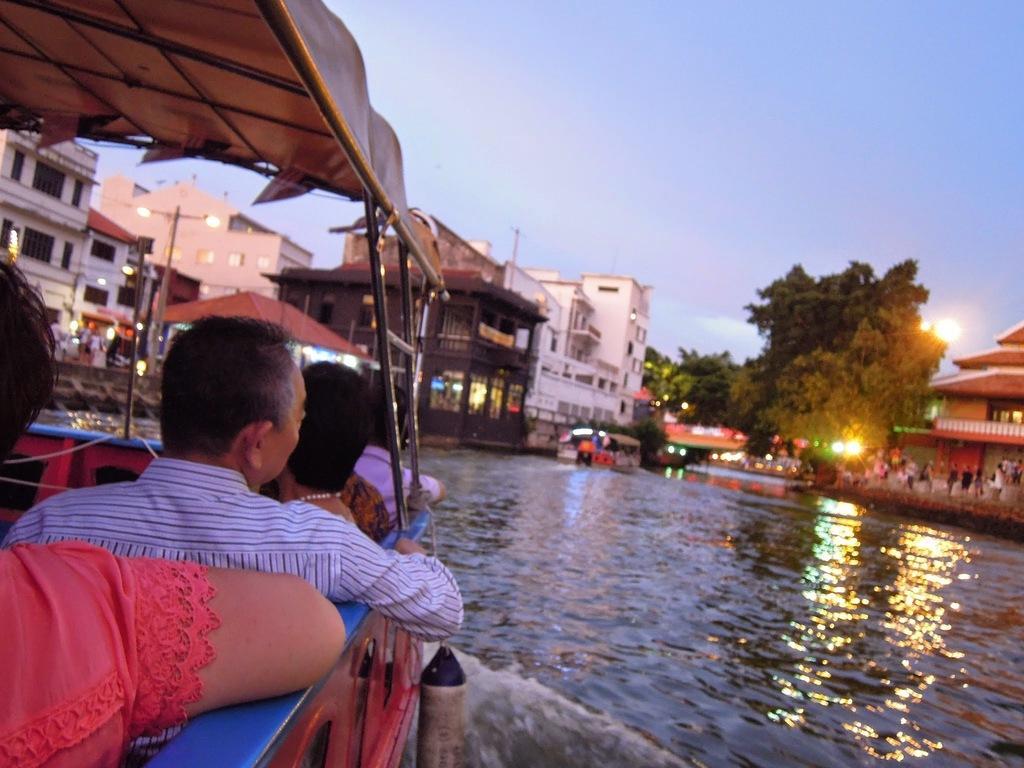Describe this image in one or two sentences. In this image we can see some people sitting in a boat which is covered with a roof in the water. On the backside we can see a house with a roof and some people standing near it. We can also see some buildings, street poles, trees, the sun and the sky which looks cloudy. 